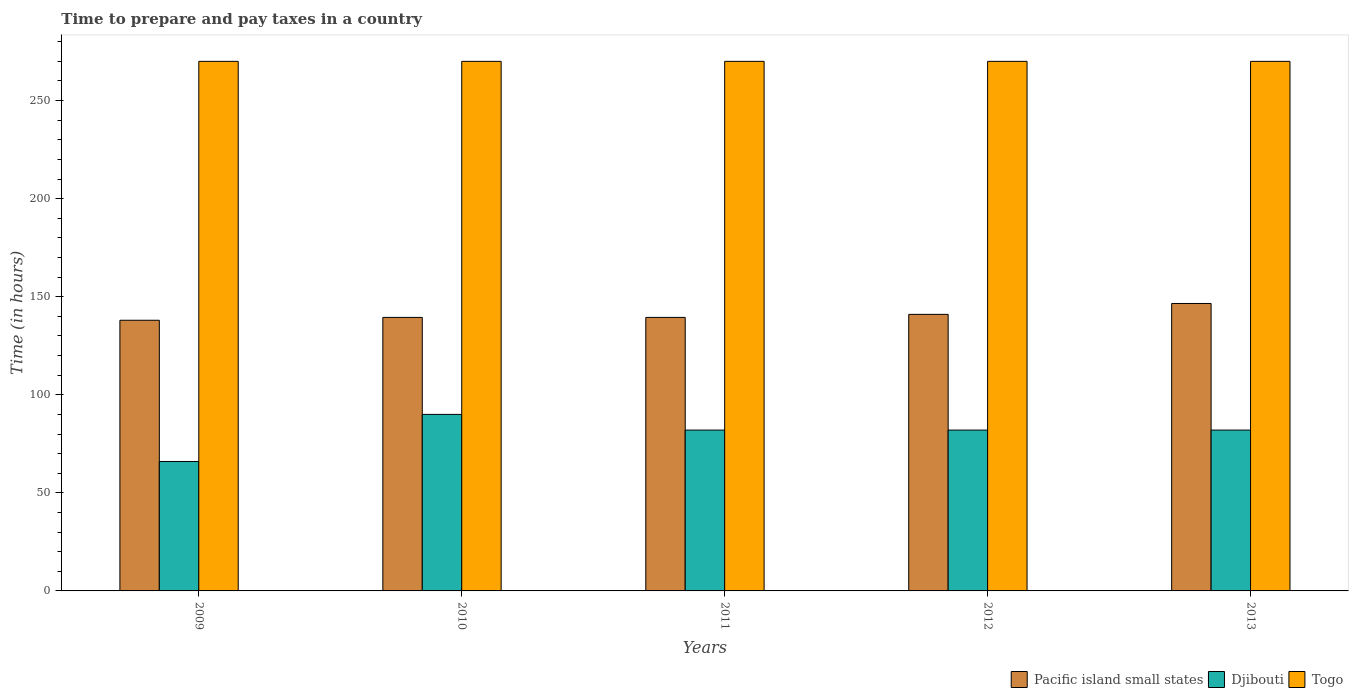How many different coloured bars are there?
Provide a succinct answer. 3. Are the number of bars per tick equal to the number of legend labels?
Keep it short and to the point. Yes. What is the label of the 5th group of bars from the left?
Offer a very short reply. 2013. In how many cases, is the number of bars for a given year not equal to the number of legend labels?
Your response must be concise. 0. What is the number of hours required to prepare and pay taxes in Djibouti in 2011?
Ensure brevity in your answer.  82. Across all years, what is the maximum number of hours required to prepare and pay taxes in Pacific island small states?
Your answer should be compact. 146.56. Across all years, what is the minimum number of hours required to prepare and pay taxes in Djibouti?
Provide a succinct answer. 66. In which year was the number of hours required to prepare and pay taxes in Djibouti maximum?
Make the answer very short. 2010. What is the total number of hours required to prepare and pay taxes in Togo in the graph?
Offer a very short reply. 1350. What is the difference between the number of hours required to prepare and pay taxes in Pacific island small states in 2009 and that in 2010?
Offer a terse response. -1.44. What is the difference between the number of hours required to prepare and pay taxes in Pacific island small states in 2011 and the number of hours required to prepare and pay taxes in Djibouti in 2009?
Your response must be concise. 73.44. What is the average number of hours required to prepare and pay taxes in Pacific island small states per year?
Make the answer very short. 140.89. In the year 2012, what is the difference between the number of hours required to prepare and pay taxes in Pacific island small states and number of hours required to prepare and pay taxes in Togo?
Provide a short and direct response. -129. What is the ratio of the number of hours required to prepare and pay taxes in Djibouti in 2009 to that in 2012?
Ensure brevity in your answer.  0.8. Is the number of hours required to prepare and pay taxes in Togo in 2012 less than that in 2013?
Your response must be concise. No. Is the difference between the number of hours required to prepare and pay taxes in Pacific island small states in 2010 and 2012 greater than the difference between the number of hours required to prepare and pay taxes in Togo in 2010 and 2012?
Ensure brevity in your answer.  No. What is the difference between the highest and the second highest number of hours required to prepare and pay taxes in Djibouti?
Offer a terse response. 8. What is the difference between the highest and the lowest number of hours required to prepare and pay taxes in Pacific island small states?
Give a very brief answer. 8.56. In how many years, is the number of hours required to prepare and pay taxes in Togo greater than the average number of hours required to prepare and pay taxes in Togo taken over all years?
Provide a short and direct response. 0. Is the sum of the number of hours required to prepare and pay taxes in Togo in 2010 and 2013 greater than the maximum number of hours required to prepare and pay taxes in Pacific island small states across all years?
Your answer should be very brief. Yes. What does the 3rd bar from the left in 2009 represents?
Give a very brief answer. Togo. What does the 2nd bar from the right in 2011 represents?
Give a very brief answer. Djibouti. How many bars are there?
Ensure brevity in your answer.  15. Does the graph contain any zero values?
Offer a terse response. No. Where does the legend appear in the graph?
Make the answer very short. Bottom right. How are the legend labels stacked?
Keep it short and to the point. Horizontal. What is the title of the graph?
Provide a succinct answer. Time to prepare and pay taxes in a country. What is the label or title of the X-axis?
Ensure brevity in your answer.  Years. What is the label or title of the Y-axis?
Offer a terse response. Time (in hours). What is the Time (in hours) in Pacific island small states in 2009?
Provide a short and direct response. 138. What is the Time (in hours) of Djibouti in 2009?
Provide a succinct answer. 66. What is the Time (in hours) of Togo in 2009?
Provide a succinct answer. 270. What is the Time (in hours) of Pacific island small states in 2010?
Offer a very short reply. 139.44. What is the Time (in hours) in Djibouti in 2010?
Offer a very short reply. 90. What is the Time (in hours) in Togo in 2010?
Offer a terse response. 270. What is the Time (in hours) in Pacific island small states in 2011?
Your answer should be compact. 139.44. What is the Time (in hours) of Djibouti in 2011?
Keep it short and to the point. 82. What is the Time (in hours) of Togo in 2011?
Provide a short and direct response. 270. What is the Time (in hours) in Pacific island small states in 2012?
Offer a very short reply. 141. What is the Time (in hours) of Togo in 2012?
Your answer should be compact. 270. What is the Time (in hours) of Pacific island small states in 2013?
Your answer should be very brief. 146.56. What is the Time (in hours) of Djibouti in 2013?
Provide a succinct answer. 82. What is the Time (in hours) of Togo in 2013?
Provide a short and direct response. 270. Across all years, what is the maximum Time (in hours) of Pacific island small states?
Provide a short and direct response. 146.56. Across all years, what is the maximum Time (in hours) in Togo?
Make the answer very short. 270. Across all years, what is the minimum Time (in hours) in Pacific island small states?
Provide a short and direct response. 138. Across all years, what is the minimum Time (in hours) in Djibouti?
Give a very brief answer. 66. Across all years, what is the minimum Time (in hours) of Togo?
Provide a short and direct response. 270. What is the total Time (in hours) of Pacific island small states in the graph?
Your answer should be very brief. 704.44. What is the total Time (in hours) in Djibouti in the graph?
Your answer should be very brief. 402. What is the total Time (in hours) in Togo in the graph?
Offer a terse response. 1350. What is the difference between the Time (in hours) of Pacific island small states in 2009 and that in 2010?
Give a very brief answer. -1.44. What is the difference between the Time (in hours) of Djibouti in 2009 and that in 2010?
Your answer should be compact. -24. What is the difference between the Time (in hours) of Pacific island small states in 2009 and that in 2011?
Your answer should be compact. -1.44. What is the difference between the Time (in hours) in Pacific island small states in 2009 and that in 2013?
Keep it short and to the point. -8.56. What is the difference between the Time (in hours) in Djibouti in 2009 and that in 2013?
Your response must be concise. -16. What is the difference between the Time (in hours) of Togo in 2009 and that in 2013?
Ensure brevity in your answer.  0. What is the difference between the Time (in hours) in Pacific island small states in 2010 and that in 2012?
Keep it short and to the point. -1.56. What is the difference between the Time (in hours) of Pacific island small states in 2010 and that in 2013?
Keep it short and to the point. -7.11. What is the difference between the Time (in hours) of Togo in 2010 and that in 2013?
Your answer should be compact. 0. What is the difference between the Time (in hours) in Pacific island small states in 2011 and that in 2012?
Make the answer very short. -1.56. What is the difference between the Time (in hours) of Djibouti in 2011 and that in 2012?
Your answer should be compact. 0. What is the difference between the Time (in hours) in Togo in 2011 and that in 2012?
Keep it short and to the point. 0. What is the difference between the Time (in hours) of Pacific island small states in 2011 and that in 2013?
Your answer should be compact. -7.11. What is the difference between the Time (in hours) of Pacific island small states in 2012 and that in 2013?
Your response must be concise. -5.56. What is the difference between the Time (in hours) in Djibouti in 2012 and that in 2013?
Give a very brief answer. 0. What is the difference between the Time (in hours) in Pacific island small states in 2009 and the Time (in hours) in Djibouti in 2010?
Your response must be concise. 48. What is the difference between the Time (in hours) of Pacific island small states in 2009 and the Time (in hours) of Togo in 2010?
Provide a succinct answer. -132. What is the difference between the Time (in hours) of Djibouti in 2009 and the Time (in hours) of Togo in 2010?
Your answer should be compact. -204. What is the difference between the Time (in hours) of Pacific island small states in 2009 and the Time (in hours) of Togo in 2011?
Your response must be concise. -132. What is the difference between the Time (in hours) of Djibouti in 2009 and the Time (in hours) of Togo in 2011?
Provide a succinct answer. -204. What is the difference between the Time (in hours) of Pacific island small states in 2009 and the Time (in hours) of Djibouti in 2012?
Ensure brevity in your answer.  56. What is the difference between the Time (in hours) of Pacific island small states in 2009 and the Time (in hours) of Togo in 2012?
Provide a succinct answer. -132. What is the difference between the Time (in hours) of Djibouti in 2009 and the Time (in hours) of Togo in 2012?
Give a very brief answer. -204. What is the difference between the Time (in hours) of Pacific island small states in 2009 and the Time (in hours) of Djibouti in 2013?
Provide a succinct answer. 56. What is the difference between the Time (in hours) of Pacific island small states in 2009 and the Time (in hours) of Togo in 2013?
Provide a succinct answer. -132. What is the difference between the Time (in hours) of Djibouti in 2009 and the Time (in hours) of Togo in 2013?
Provide a succinct answer. -204. What is the difference between the Time (in hours) in Pacific island small states in 2010 and the Time (in hours) in Djibouti in 2011?
Make the answer very short. 57.44. What is the difference between the Time (in hours) of Pacific island small states in 2010 and the Time (in hours) of Togo in 2011?
Make the answer very short. -130.56. What is the difference between the Time (in hours) of Djibouti in 2010 and the Time (in hours) of Togo in 2011?
Offer a very short reply. -180. What is the difference between the Time (in hours) of Pacific island small states in 2010 and the Time (in hours) of Djibouti in 2012?
Your response must be concise. 57.44. What is the difference between the Time (in hours) in Pacific island small states in 2010 and the Time (in hours) in Togo in 2012?
Your response must be concise. -130.56. What is the difference between the Time (in hours) in Djibouti in 2010 and the Time (in hours) in Togo in 2012?
Ensure brevity in your answer.  -180. What is the difference between the Time (in hours) in Pacific island small states in 2010 and the Time (in hours) in Djibouti in 2013?
Your answer should be compact. 57.44. What is the difference between the Time (in hours) in Pacific island small states in 2010 and the Time (in hours) in Togo in 2013?
Give a very brief answer. -130.56. What is the difference between the Time (in hours) in Djibouti in 2010 and the Time (in hours) in Togo in 2013?
Offer a very short reply. -180. What is the difference between the Time (in hours) of Pacific island small states in 2011 and the Time (in hours) of Djibouti in 2012?
Your response must be concise. 57.44. What is the difference between the Time (in hours) of Pacific island small states in 2011 and the Time (in hours) of Togo in 2012?
Offer a very short reply. -130.56. What is the difference between the Time (in hours) in Djibouti in 2011 and the Time (in hours) in Togo in 2012?
Keep it short and to the point. -188. What is the difference between the Time (in hours) in Pacific island small states in 2011 and the Time (in hours) in Djibouti in 2013?
Your answer should be very brief. 57.44. What is the difference between the Time (in hours) of Pacific island small states in 2011 and the Time (in hours) of Togo in 2013?
Offer a terse response. -130.56. What is the difference between the Time (in hours) of Djibouti in 2011 and the Time (in hours) of Togo in 2013?
Keep it short and to the point. -188. What is the difference between the Time (in hours) of Pacific island small states in 2012 and the Time (in hours) of Djibouti in 2013?
Your answer should be very brief. 59. What is the difference between the Time (in hours) in Pacific island small states in 2012 and the Time (in hours) in Togo in 2013?
Provide a short and direct response. -129. What is the difference between the Time (in hours) in Djibouti in 2012 and the Time (in hours) in Togo in 2013?
Give a very brief answer. -188. What is the average Time (in hours) of Pacific island small states per year?
Offer a terse response. 140.89. What is the average Time (in hours) in Djibouti per year?
Offer a very short reply. 80.4. What is the average Time (in hours) in Togo per year?
Offer a very short reply. 270. In the year 2009, what is the difference between the Time (in hours) of Pacific island small states and Time (in hours) of Togo?
Your answer should be compact. -132. In the year 2009, what is the difference between the Time (in hours) in Djibouti and Time (in hours) in Togo?
Give a very brief answer. -204. In the year 2010, what is the difference between the Time (in hours) of Pacific island small states and Time (in hours) of Djibouti?
Make the answer very short. 49.44. In the year 2010, what is the difference between the Time (in hours) of Pacific island small states and Time (in hours) of Togo?
Your answer should be compact. -130.56. In the year 2010, what is the difference between the Time (in hours) in Djibouti and Time (in hours) in Togo?
Make the answer very short. -180. In the year 2011, what is the difference between the Time (in hours) in Pacific island small states and Time (in hours) in Djibouti?
Provide a short and direct response. 57.44. In the year 2011, what is the difference between the Time (in hours) in Pacific island small states and Time (in hours) in Togo?
Your answer should be compact. -130.56. In the year 2011, what is the difference between the Time (in hours) in Djibouti and Time (in hours) in Togo?
Make the answer very short. -188. In the year 2012, what is the difference between the Time (in hours) in Pacific island small states and Time (in hours) in Togo?
Provide a succinct answer. -129. In the year 2012, what is the difference between the Time (in hours) in Djibouti and Time (in hours) in Togo?
Offer a very short reply. -188. In the year 2013, what is the difference between the Time (in hours) in Pacific island small states and Time (in hours) in Djibouti?
Give a very brief answer. 64.56. In the year 2013, what is the difference between the Time (in hours) of Pacific island small states and Time (in hours) of Togo?
Ensure brevity in your answer.  -123.44. In the year 2013, what is the difference between the Time (in hours) of Djibouti and Time (in hours) of Togo?
Keep it short and to the point. -188. What is the ratio of the Time (in hours) in Pacific island small states in 2009 to that in 2010?
Your response must be concise. 0.99. What is the ratio of the Time (in hours) of Djibouti in 2009 to that in 2010?
Make the answer very short. 0.73. What is the ratio of the Time (in hours) of Pacific island small states in 2009 to that in 2011?
Provide a short and direct response. 0.99. What is the ratio of the Time (in hours) of Djibouti in 2009 to that in 2011?
Provide a short and direct response. 0.8. What is the ratio of the Time (in hours) of Togo in 2009 to that in 2011?
Ensure brevity in your answer.  1. What is the ratio of the Time (in hours) of Pacific island small states in 2009 to that in 2012?
Give a very brief answer. 0.98. What is the ratio of the Time (in hours) in Djibouti in 2009 to that in 2012?
Provide a succinct answer. 0.8. What is the ratio of the Time (in hours) in Togo in 2009 to that in 2012?
Provide a succinct answer. 1. What is the ratio of the Time (in hours) in Pacific island small states in 2009 to that in 2013?
Offer a terse response. 0.94. What is the ratio of the Time (in hours) in Djibouti in 2009 to that in 2013?
Ensure brevity in your answer.  0.8. What is the ratio of the Time (in hours) of Pacific island small states in 2010 to that in 2011?
Ensure brevity in your answer.  1. What is the ratio of the Time (in hours) of Djibouti in 2010 to that in 2011?
Make the answer very short. 1.1. What is the ratio of the Time (in hours) in Pacific island small states in 2010 to that in 2012?
Ensure brevity in your answer.  0.99. What is the ratio of the Time (in hours) of Djibouti in 2010 to that in 2012?
Ensure brevity in your answer.  1.1. What is the ratio of the Time (in hours) in Togo in 2010 to that in 2012?
Give a very brief answer. 1. What is the ratio of the Time (in hours) in Pacific island small states in 2010 to that in 2013?
Give a very brief answer. 0.95. What is the ratio of the Time (in hours) of Djibouti in 2010 to that in 2013?
Make the answer very short. 1.1. What is the ratio of the Time (in hours) of Pacific island small states in 2011 to that in 2012?
Your answer should be compact. 0.99. What is the ratio of the Time (in hours) of Pacific island small states in 2011 to that in 2013?
Keep it short and to the point. 0.95. What is the ratio of the Time (in hours) in Togo in 2011 to that in 2013?
Give a very brief answer. 1. What is the ratio of the Time (in hours) of Pacific island small states in 2012 to that in 2013?
Ensure brevity in your answer.  0.96. What is the ratio of the Time (in hours) in Djibouti in 2012 to that in 2013?
Give a very brief answer. 1. What is the ratio of the Time (in hours) of Togo in 2012 to that in 2013?
Your answer should be compact. 1. What is the difference between the highest and the second highest Time (in hours) of Pacific island small states?
Give a very brief answer. 5.56. What is the difference between the highest and the second highest Time (in hours) of Djibouti?
Offer a terse response. 8. What is the difference between the highest and the second highest Time (in hours) of Togo?
Offer a very short reply. 0. What is the difference between the highest and the lowest Time (in hours) of Pacific island small states?
Your answer should be compact. 8.56. What is the difference between the highest and the lowest Time (in hours) of Djibouti?
Ensure brevity in your answer.  24. What is the difference between the highest and the lowest Time (in hours) of Togo?
Ensure brevity in your answer.  0. 